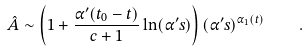<formula> <loc_0><loc_0><loc_500><loc_500>\hat { A } \sim \left ( 1 + \frac { \alpha ^ { \prime } ( t _ { 0 } - t ) } { c + 1 } \ln ( \alpha ^ { \prime } s ) \right ) ( \alpha ^ { \prime } s ) ^ { \alpha _ { 1 } ( t ) } \quad .</formula> 